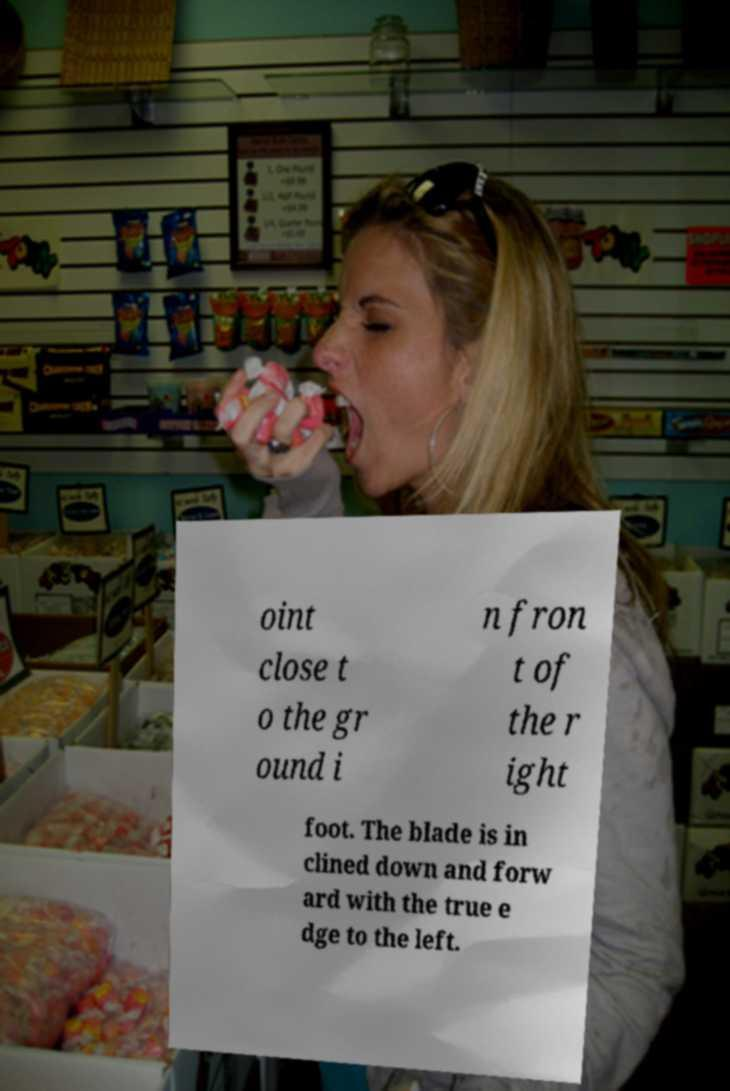Can you accurately transcribe the text from the provided image for me? oint close t o the gr ound i n fron t of the r ight foot. The blade is in clined down and forw ard with the true e dge to the left. 